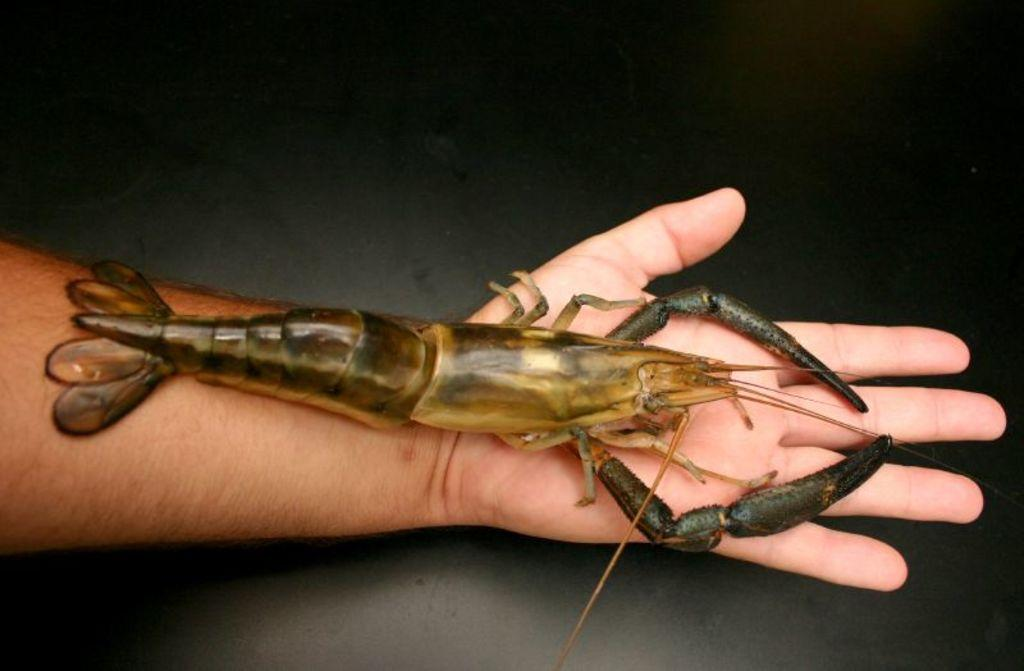Who or what is the main subject in the center of the picture? There is a person in the center of the picture. What is the person holding in the image? The person is holding a shrimp. What can be seen in the background of the image? There is a floor visible in the background of the image. How many geese are flying over the person in the image? There are no geese visible in the image. What type of wheel is attached to the person's foot in the image? There is no wheel present in the image. 